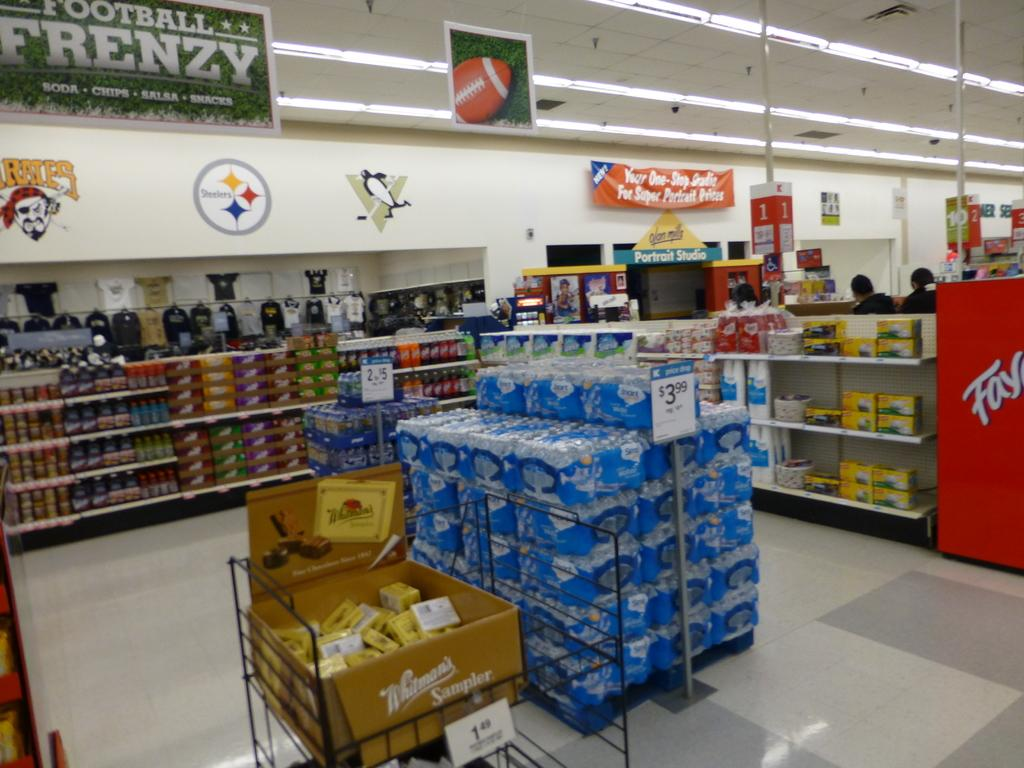Provide a one-sentence caption for the provided image. A Football Frenzy banner hangs high on the wall of a grocery store. 